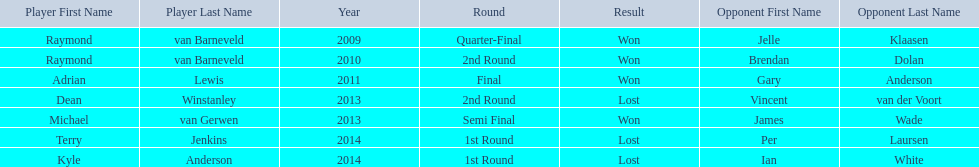Name a year with more than one game listed. 2013. 